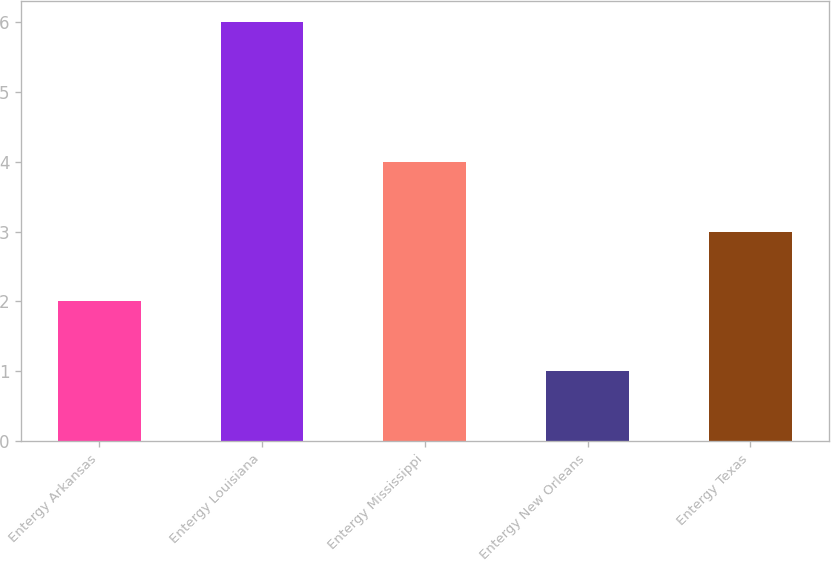Convert chart. <chart><loc_0><loc_0><loc_500><loc_500><bar_chart><fcel>Entergy Arkansas<fcel>Entergy Louisiana<fcel>Entergy Mississippi<fcel>Entergy New Orleans<fcel>Entergy Texas<nl><fcel>2<fcel>6<fcel>4<fcel>1<fcel>3<nl></chart> 